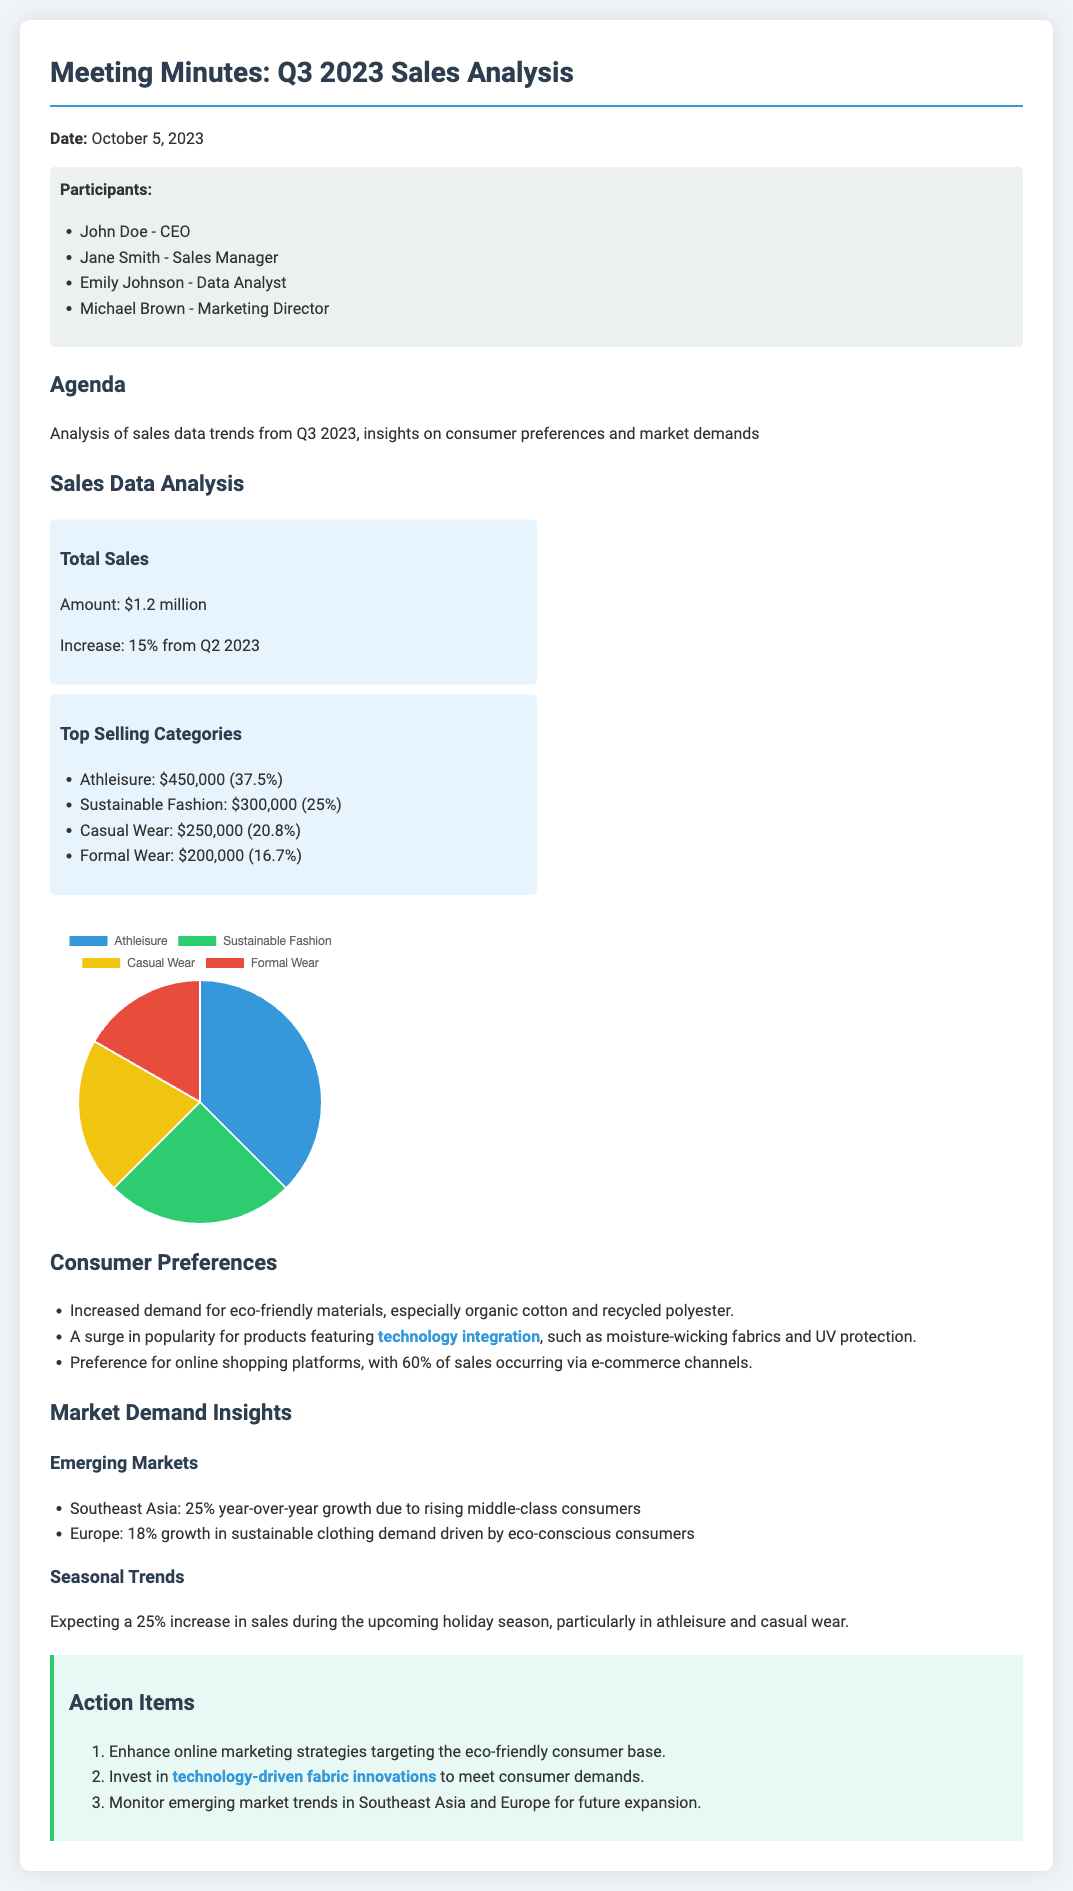What is the total sales amount for Q3 2023? The total sales amount is explicitly stated in the document under "Total Sales."
Answer: $1.2 million What percentage increase in sales is reported from Q2 2023? The increase from Q2 2023 is mentioned as 15%.
Answer: 15% Which category generated the highest sales? The category with the highest sales is found in the "Top Selling Categories" section.
Answer: Athleisure: $450,000 What is the preferred material among consumers in Q3 2023? The document states consumer preferences regarding materials, particularly eco-friendly ones.
Answer: Organic cotton and recycled polyester What is the expected sales increase during the holiday season? The expected sales increase is detailed under the "Seasonal Trends" section.
Answer: 25% What is the main market showing year-over-year growth? The document highlights Southeast Asia as an emerging market with growth.
Answer: Southeast Asia How much of total sales occurred via e-commerce platforms? The document specifies that 60% of total sales were through e-commerce channels.
Answer: 60% What is the action item related to technology-driven contributions? The action items include a specific focus on technology-driven innovations according to "Action Items."
Answer: Invest in technology-driven fabric innovations Who were the participants in the meeting? The participants are listed in the "Participants" section of the document.
Answer: John Doe, Jane Smith, Emily Johnson, Michael Brown 